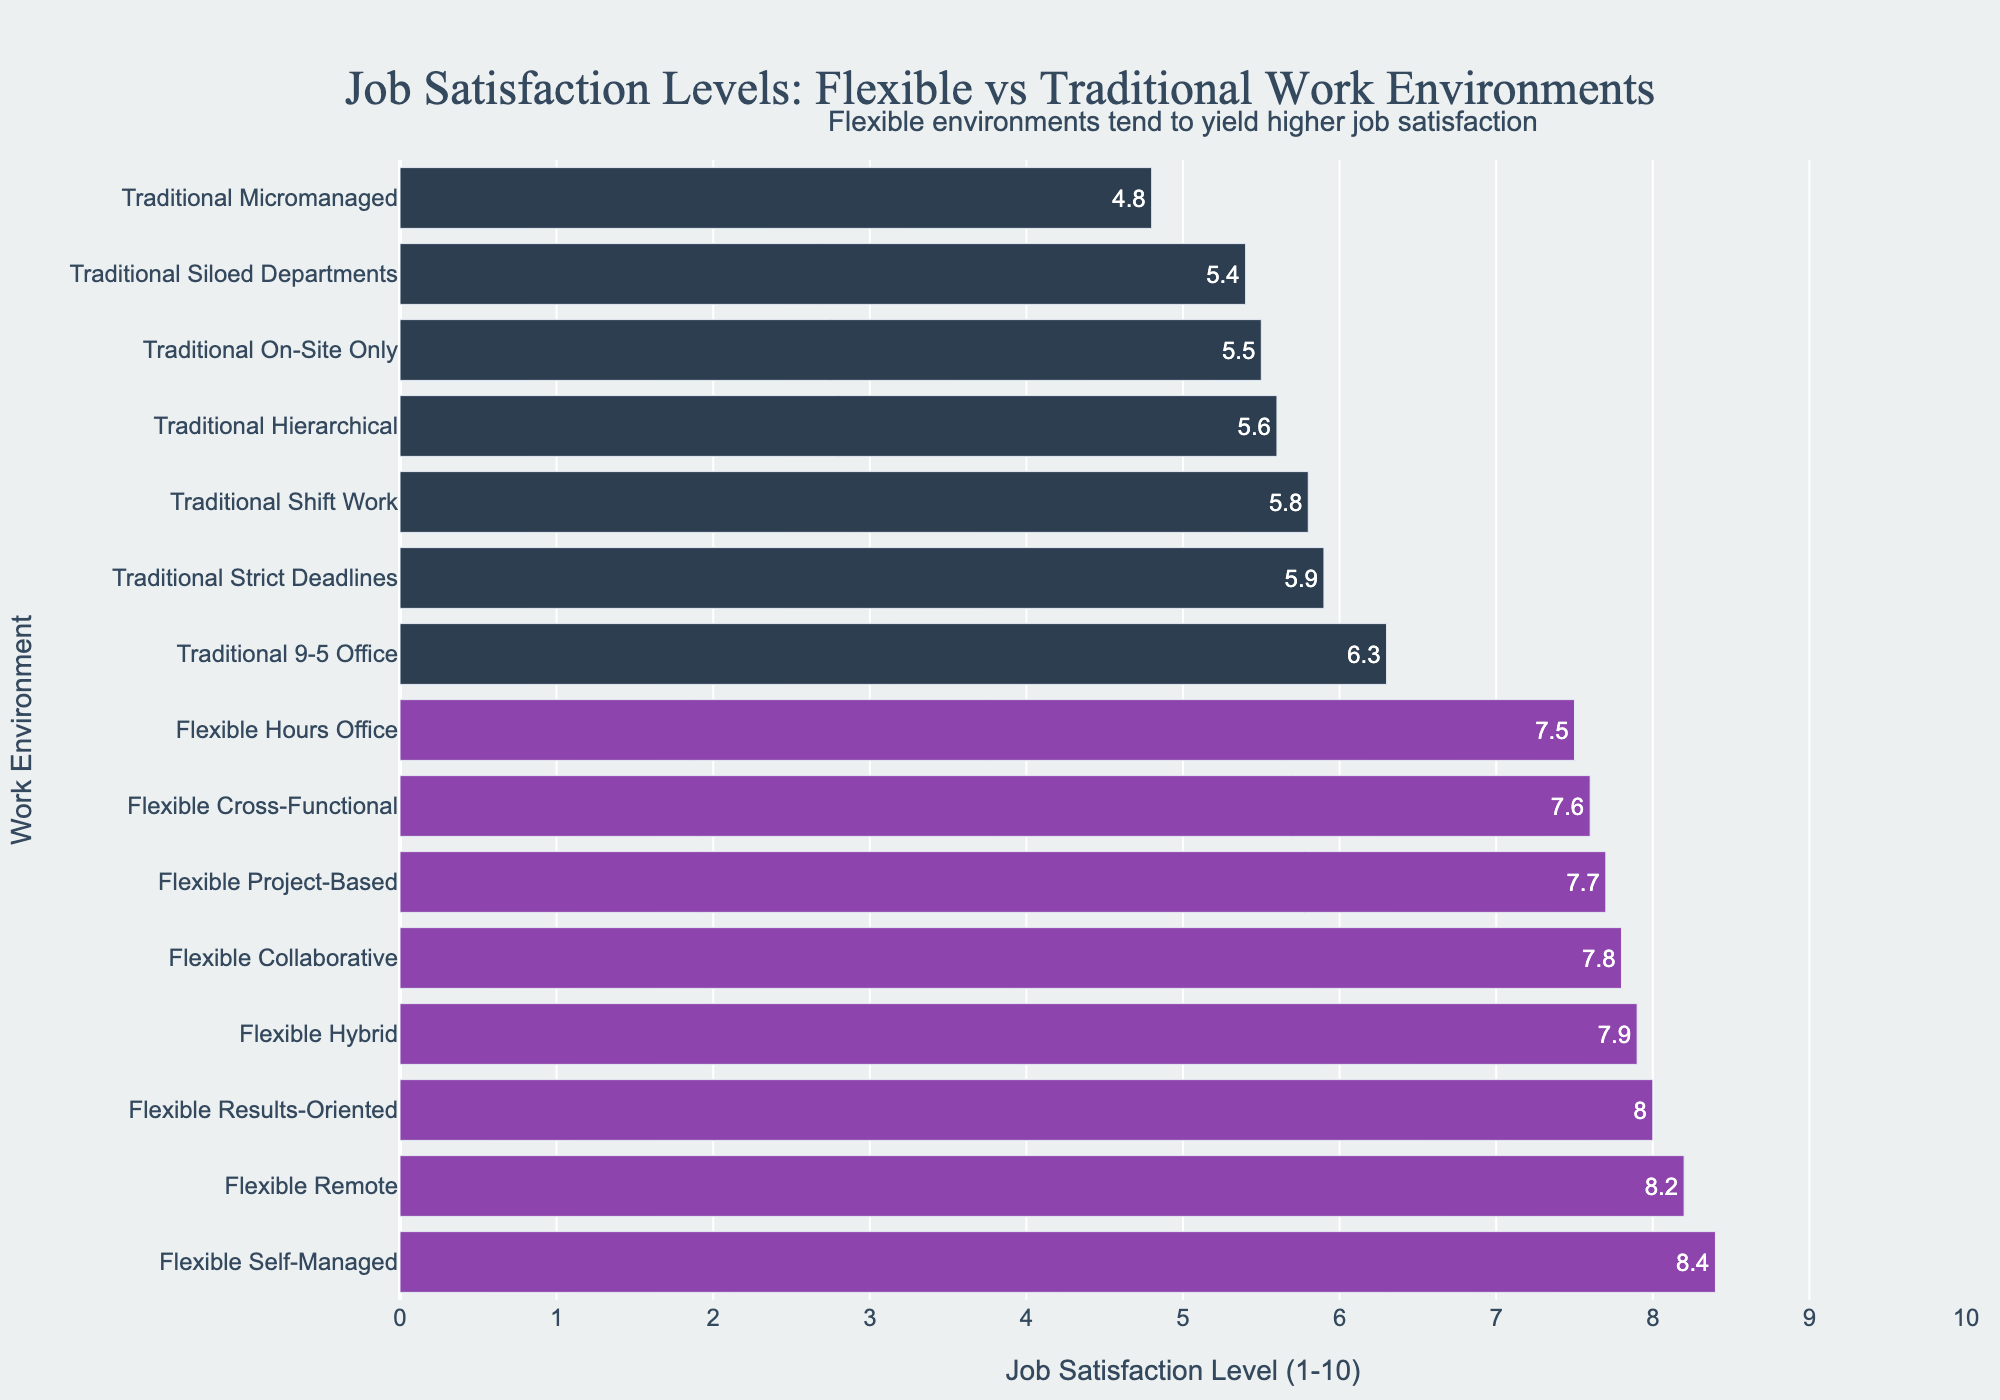what is the highest job satisfaction level among the flexible work environments and which environment does it belong to? The highest job satisfaction level for flexible work environments is 8.4, which belongs to the 'Flexible Self-Managed' environment. This can be observed by identifying the maximum value among the flexible work environments on the bar chart.
Answer: 8.4, Flexible Self-Managed What is the median job satisfaction level for the traditional work environments? To find the median job satisfaction level of traditional work environments, list the traditional environments in ascending order: 4.8, 5.4, 5.5, 5.6, 5.8, 5.9, 6.3. The median is the middle number, which is 5.6.
Answer: 5.6 Which work environment shows the lowest job satisfaction level and what is its value? Identify the shortest bar in the chart. The 'Traditional Micromanaged' environment is the lowest with a job satisfaction level of 4.8.
Answer: Traditional Micromanaged, 4.8 How much higher is the job satisfaction level for 'Flexible Remote' compared to 'Traditional On-Site Only'? The job satisfaction level for 'Flexible Remote' is 8.2, and for 'Traditional On-Site Only' it is 5.5. The difference is calculated as 8.2 - 5.5 = 2.7.
Answer: 2.7 What is the average job satisfaction level for flexible work environments? Sum the job satisfaction levels of the flexible environments: 8.2, 7.9, 7.5, 7.7, 8.0, 8.4, 7.8, 7.6. The sum is 63.1, and there are 8 environments. The average is 63.1 / 8 = 7.8875.
Answer: 7.8875 Which flexible work environments have a job satisfaction level higher than the highest traditional work environment? The highest traditional work environment job satisfaction level is 'Traditional 9-5 Office' at 6.3. Flexible work environments higher than this include: 'Flexible Remote' (8.2), 'Flexible Hybrid' (7.9), 'Flexible Project-Based' (7.7), 'Flexible Results-Oriented' (8.0), 'Flexible Self-Managed' (8.4), 'Flexible Collaborative' (7.8), 'Flexible Cross-Functional' (7.6).
Answer: Flexible Remote, Flexible Hybrid, Flexible Project-Based, Flexible Results-Oriented, Flexible Self-Managed, Flexible Collaborative, Flexible Cross-Functional Do more flexible or traditional work environments fall below a job satisfaction level of 6? Based on the figure, traditional work environments have more entries below 6: 'Traditional Shift Work' (5.8), 'Traditional On-Site Only' (5.5), 'Traditional Strict Deadlines' (5.9), 'Traditional Micromanaged' (4.8), 'Traditional Hierarchical' (5.6), 'Traditional Siloed Departments' (5.4) – totaling 6 environments. Only one flexible environment is below 6: 'Flexible Hours Office' (7.5), which is above 6. So, traditional has more.
Answer: Traditional environments Is there a correlation between flexibility in the work environment and job satisfaction levels? By comparing the job satisfaction levels, you can see that the flexible work environments generally have higher job satisfaction levels compared to traditional ones. This can be deduced from the patterns in the bar lengths and positions.
Answer: Yes 